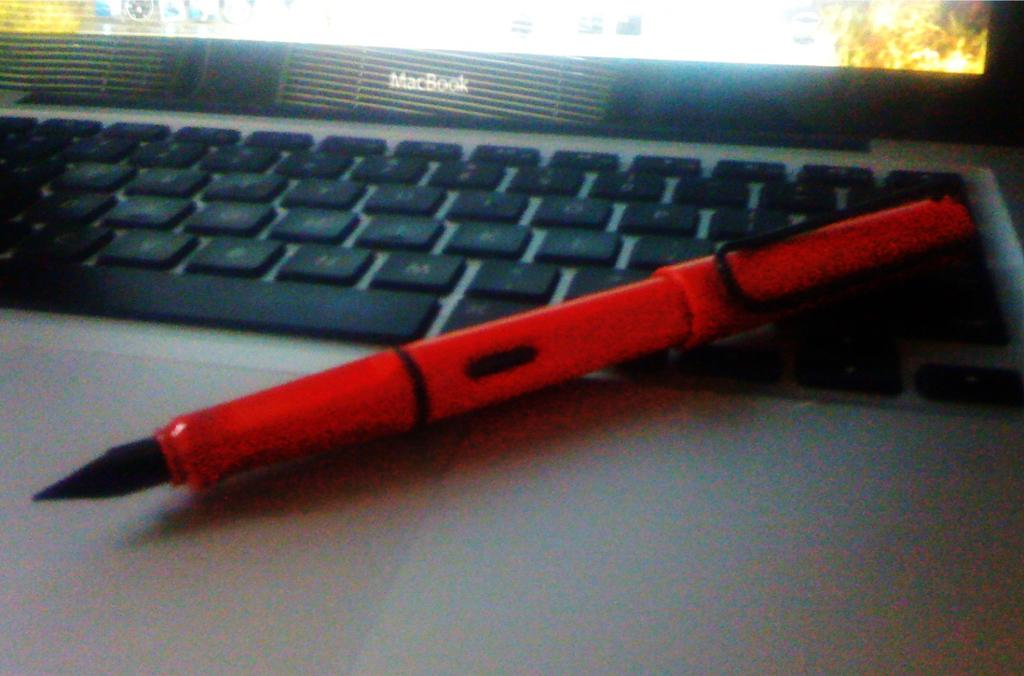What type of writing instrument is in the image? There is a red and black color pen in the image. Where is the pen located in the image? The pen is on a laptop. Can you see any pears or cabbages in the image? There are no pears or cabbages present in the image. 